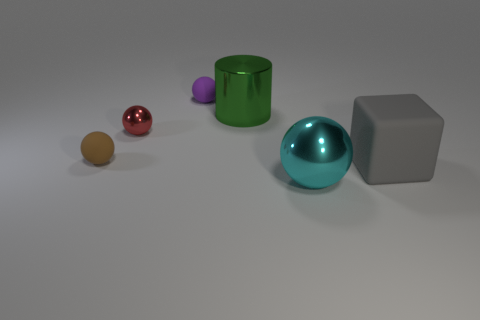Is the number of brown matte things greater than the number of green spheres?
Make the answer very short. Yes. Is the number of big metal balls that are on the right side of the gray matte thing greater than the number of small brown rubber things that are right of the green metal object?
Make the answer very short. No. There is a metallic thing that is on the right side of the purple matte sphere and behind the cyan ball; how big is it?
Ensure brevity in your answer.  Large. How many matte balls are the same size as the green metal object?
Keep it short and to the point. 0. There is a big green metallic thing behind the large gray block; does it have the same shape as the tiny brown matte thing?
Make the answer very short. No. Is the number of purple spheres on the left side of the red shiny thing less than the number of large green balls?
Your response must be concise. No. Are there any big metal cylinders that have the same color as the large rubber thing?
Offer a terse response. No. Does the purple matte thing have the same shape as the large metallic object behind the large rubber cube?
Your response must be concise. No. Are there any green objects made of the same material as the brown object?
Provide a short and direct response. No. Are there any purple objects in front of the rubber ball that is on the left side of the small rubber ball that is behind the tiny metallic object?
Provide a short and direct response. No. 